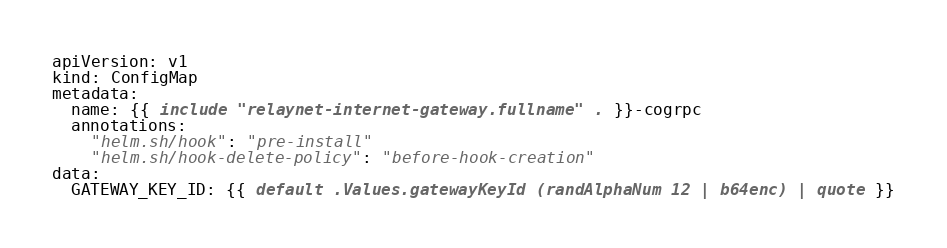Convert code to text. <code><loc_0><loc_0><loc_500><loc_500><_YAML_>apiVersion: v1
kind: ConfigMap
metadata:
  name: {{ include "relaynet-internet-gateway.fullname" . }}-cogrpc
  annotations:
    "helm.sh/hook": "pre-install"
    "helm.sh/hook-delete-policy": "before-hook-creation"
data:
  GATEWAY_KEY_ID: {{ default .Values.gatewayKeyId (randAlphaNum 12 | b64enc) | quote }}
</code> 